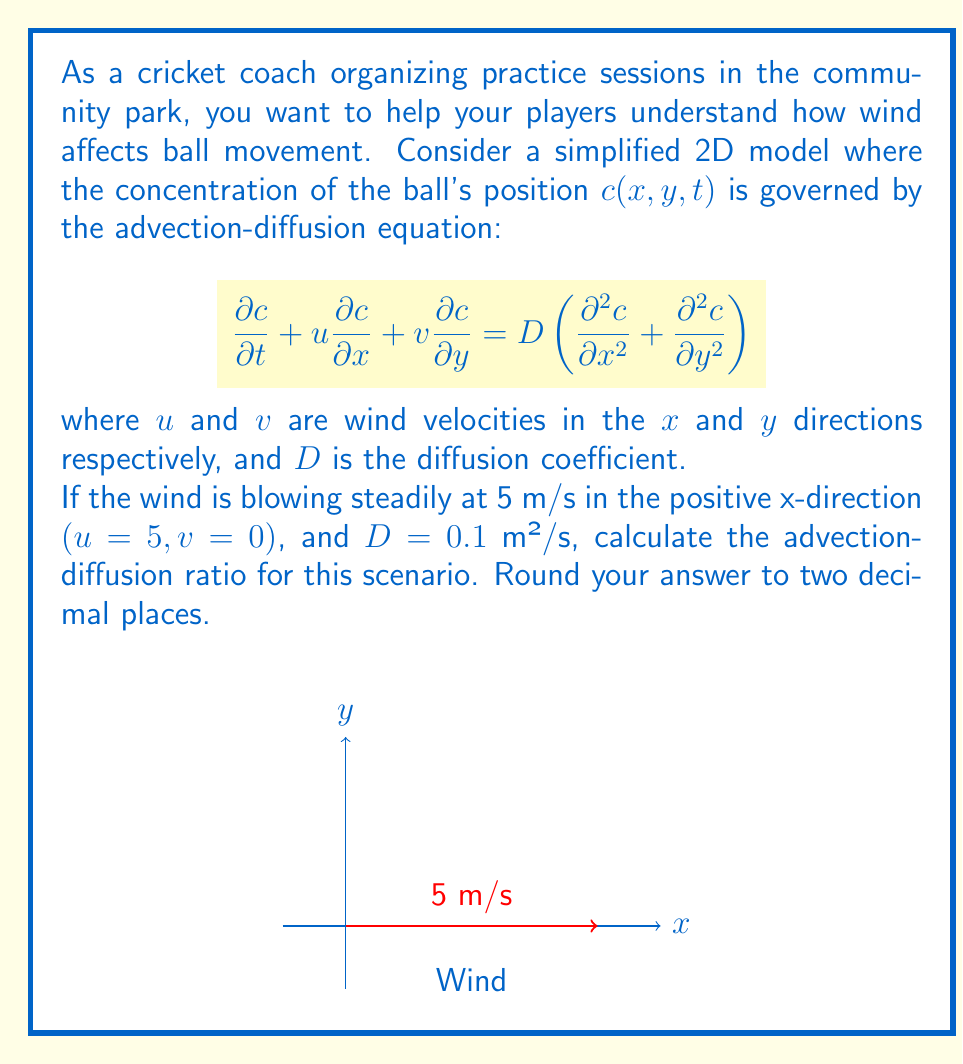Provide a solution to this math problem. To solve this problem, we need to understand the concept of the advection-diffusion ratio, also known as the Péclet number. This dimensionless number represents the ratio of the rate of advection to the rate of diffusion.

Step 1: Recall the formula for the Péclet number (Pe):
$$ Pe = \frac{UL}{D} $$
where $U$ is the characteristic velocity, $L$ is the characteristic length, and $D$ is the diffusion coefficient.

Step 2: In this case, we are given:
- $u = 5$ m/s (wind velocity in x-direction)
- $v = 0$ m/s (no wind in y-direction)
- $D = 0.1$ m²/s (diffusion coefficient)

Step 3: We need to determine a characteristic length $L$. Since no specific length is given, we can assume a unit length of 1 meter for our calculation.

Step 4: Calculate the Péclet number:
$$ Pe = \frac{UL}{D} = \frac{5 \text{ m/s} \times 1 \text{ m}}{0.1 \text{ m}^2/\text{s}} = 50 $$

Step 5: Round the result to two decimal places:
$$ Pe \approx 50.00 $$

This high Péclet number indicates that advection (wind-driven movement) dominates over diffusion in this scenario, which means the wind will have a significant effect on the ball's movement.
Answer: 50.00 